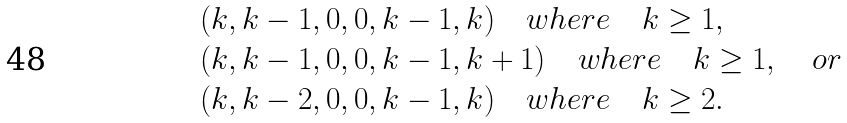<formula> <loc_0><loc_0><loc_500><loc_500>& ( k , k - 1 , 0 , 0 , k - 1 , k ) \quad w h e r e \quad k \geq 1 , \\ & ( k , k - 1 , 0 , 0 , k - 1 , k + 1 ) \quad w h e r e \quad k \geq 1 , \quad o r \\ & ( k , k - 2 , 0 , 0 , k - 1 , k ) \quad w h e r e \quad k \geq 2 .</formula> 